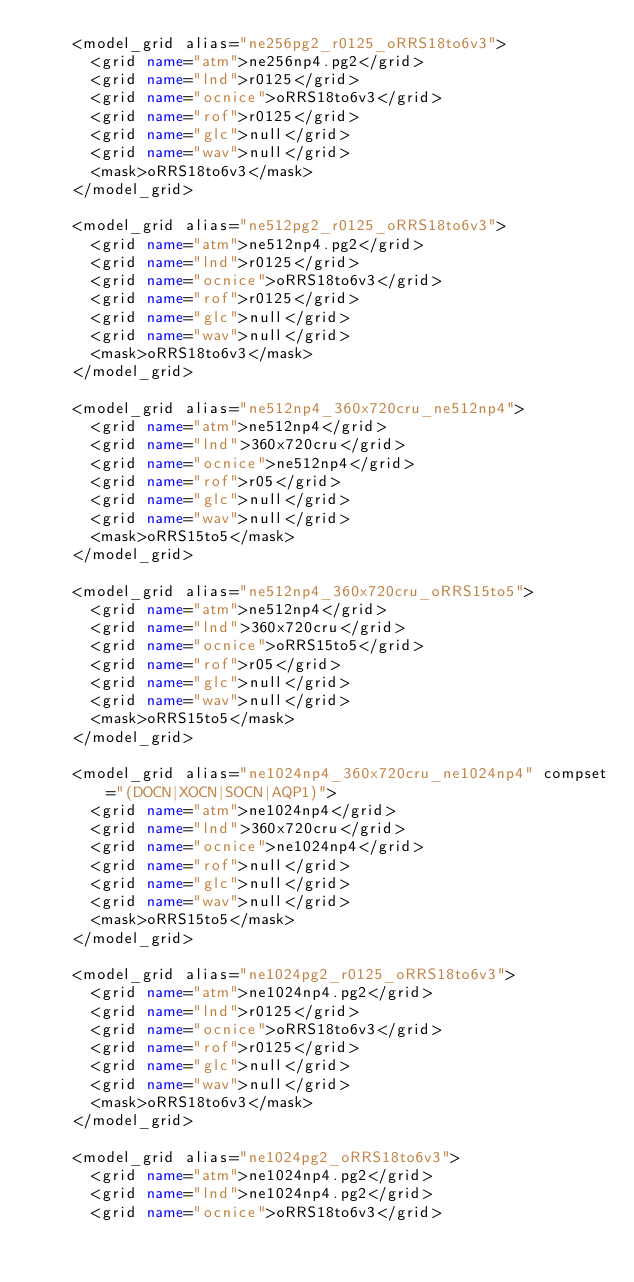<code> <loc_0><loc_0><loc_500><loc_500><_XML_>    <model_grid alias="ne256pg2_r0125_oRRS18to6v3">
      <grid name="atm">ne256np4.pg2</grid>
      <grid name="lnd">r0125</grid>
      <grid name="ocnice">oRRS18to6v3</grid>
      <grid name="rof">r0125</grid>
      <grid name="glc">null</grid>
      <grid name="wav">null</grid>
      <mask>oRRS18to6v3</mask>
    </model_grid>

    <model_grid alias="ne512pg2_r0125_oRRS18to6v3">
      <grid name="atm">ne512np4.pg2</grid>
      <grid name="lnd">r0125</grid>
      <grid name="ocnice">oRRS18to6v3</grid>
      <grid name="rof">r0125</grid>
      <grid name="glc">null</grid>
      <grid name="wav">null</grid>
      <mask>oRRS18to6v3</mask>
    </model_grid>

    <model_grid alias="ne512np4_360x720cru_ne512np4">
      <grid name="atm">ne512np4</grid>
      <grid name="lnd">360x720cru</grid>
      <grid name="ocnice">ne512np4</grid>
      <grid name="rof">r05</grid>
      <grid name="glc">null</grid>
      <grid name="wav">null</grid>
      <mask>oRRS15to5</mask>
    </model_grid>

    <model_grid alias="ne512np4_360x720cru_oRRS15to5">
      <grid name="atm">ne512np4</grid>
      <grid name="lnd">360x720cru</grid>
      <grid name="ocnice">oRRS15to5</grid>
      <grid name="rof">r05</grid>
      <grid name="glc">null</grid>
      <grid name="wav">null</grid>
      <mask>oRRS15to5</mask>
    </model_grid>

    <model_grid alias="ne1024np4_360x720cru_ne1024np4" compset="(DOCN|XOCN|SOCN|AQP1)">
      <grid name="atm">ne1024np4</grid>
      <grid name="lnd">360x720cru</grid>
      <grid name="ocnice">ne1024np4</grid>
      <grid name="rof">null</grid>
      <grid name="glc">null</grid>
      <grid name="wav">null</grid>
      <mask>oRRS15to5</mask>
    </model_grid>

    <model_grid alias="ne1024pg2_r0125_oRRS18to6v3">
      <grid name="atm">ne1024np4.pg2</grid>
      <grid name="lnd">r0125</grid>
      <grid name="ocnice">oRRS18to6v3</grid>
      <grid name="rof">r0125</grid>
      <grid name="glc">null</grid>
      <grid name="wav">null</grid>
      <mask>oRRS18to6v3</mask>
    </model_grid>

    <model_grid alias="ne1024pg2_oRRS18to6v3">
      <grid name="atm">ne1024np4.pg2</grid>
      <grid name="lnd">ne1024np4.pg2</grid>
      <grid name="ocnice">oRRS18to6v3</grid></code> 